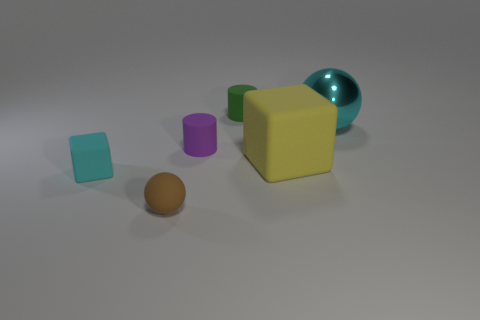Add 1 matte spheres. How many objects exist? 7 Subtract all cylinders. How many objects are left? 4 Subtract all green rubber blocks. Subtract all cyan rubber things. How many objects are left? 5 Add 4 tiny cyan rubber cubes. How many tiny cyan rubber cubes are left? 5 Add 6 small green rubber cylinders. How many small green rubber cylinders exist? 7 Subtract 0 purple blocks. How many objects are left? 6 